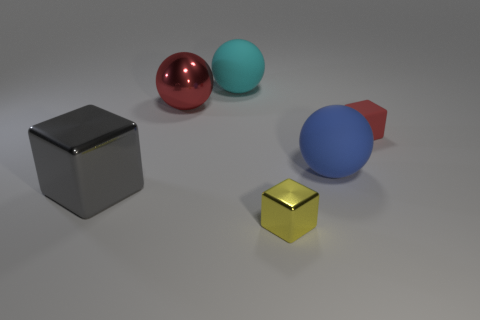What does the arrangement of the objects convey to you? The arrangement of objects within the image seems intentionally composed to demonstrate contrast and comparison. Not only do the objects vary in color and material finish, which is visually compelling, but they also seem to represent both randomness and balance. The black cube and golden cube provide grounding elements in the picture, while the spheres allude to movement or continuity. The red cone offers a directional contrast, adding to the dynamism of the scene. 